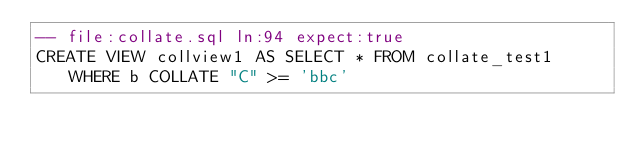<code> <loc_0><loc_0><loc_500><loc_500><_SQL_>-- file:collate.sql ln:94 expect:true
CREATE VIEW collview1 AS SELECT * FROM collate_test1 WHERE b COLLATE "C" >= 'bbc'
</code> 